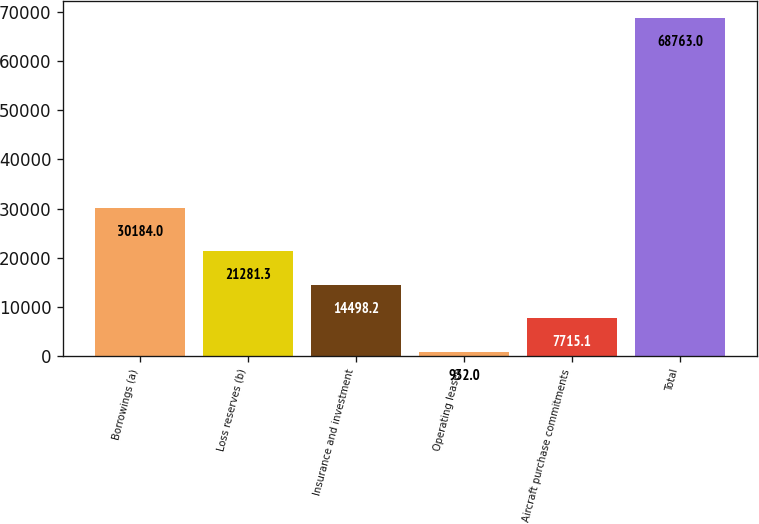Convert chart. <chart><loc_0><loc_0><loc_500><loc_500><bar_chart><fcel>Borrowings (a)<fcel>Loss reserves (b)<fcel>Insurance and investment<fcel>Operating leases<fcel>Aircraft purchase commitments<fcel>Total<nl><fcel>30184<fcel>21281.3<fcel>14498.2<fcel>932<fcel>7715.1<fcel>68763<nl></chart> 